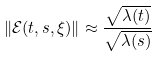Convert formula to latex. <formula><loc_0><loc_0><loc_500><loc_500>\| \mathcal { E } ( t , s , \xi ) \| \approx \frac { \sqrt { \lambda ( t ) } } { \sqrt { \lambda ( s ) } }</formula> 